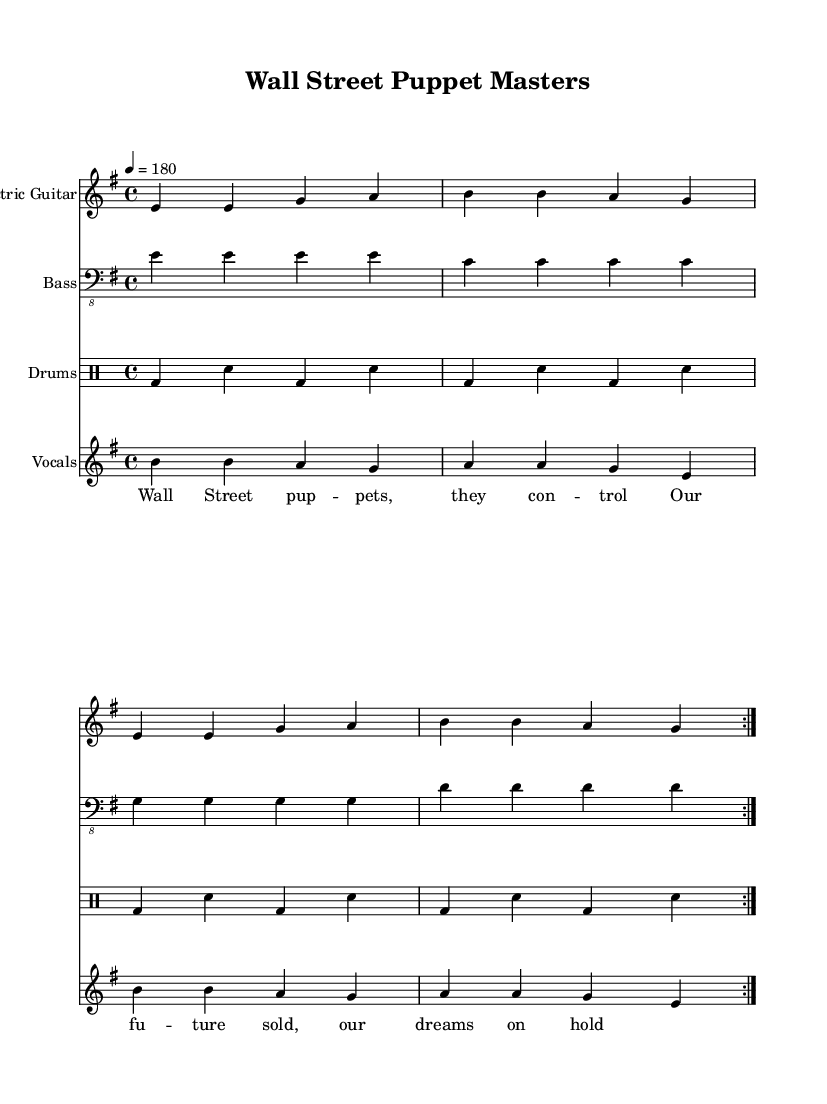What is the key signature of this music? The key signature indicates E minor, which contains one sharp (F#). It is determined by looking at the key signature notation on the staff.
Answer: E minor What is the time signature of this music? The time signature is 4/4, which is shown at the beginning of the piece. This means there are four beats in each measure.
Answer: 4/4 What is the tempo of this piece? The tempo is marked as 4 = 180. This means there are 180 beats per minute, which is indicated in the tempo marking at the beginning.
Answer: 180 How many measures are repeated in the electric guitar part? The electric guitar part repeats twice, as indicated by the "volta 2" marking in the sheet music. Each section is designed to loop back after the first play.
Answer: 2 What is the primary theme of the lyrics in the chorus? The lyrics in the chorus focus on the control exerted by Wall Street, depicting a sense of loss regarding the future and dreams, as expressed through the lyrics provided. The thematic connection relates directly to the influence of financial entities on society.
Answer: Control What instruments are present in this piece of music? The piece features electric guitar, bass, drums, and vocals, as indicated by the separate staves labeled for each instrument.
Answer: Electric guitar, bass, drums, vocals What type of music is this? This piece is categorized as Punk music, which is characterized by its politically charged lyrics often addressing social issues, as illustrated by the thematic content related to Wall Street.
Answer: Punk 